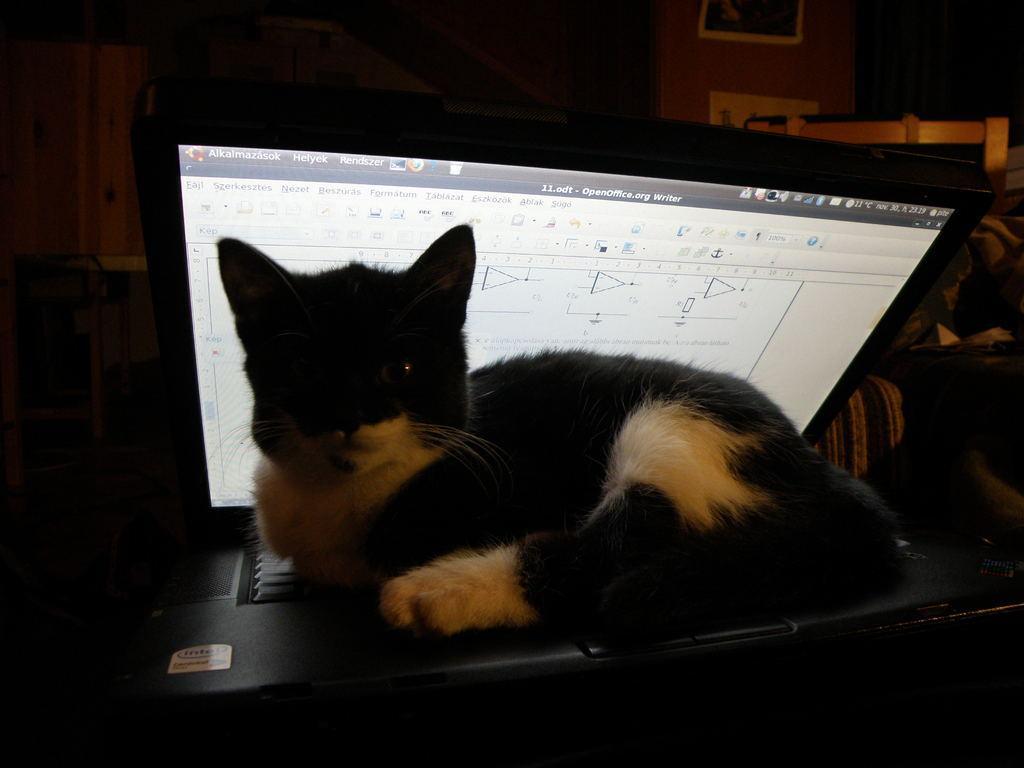Can you describe this image briefly? In this image there is a cat sat on the laptop. The background is a dark. 